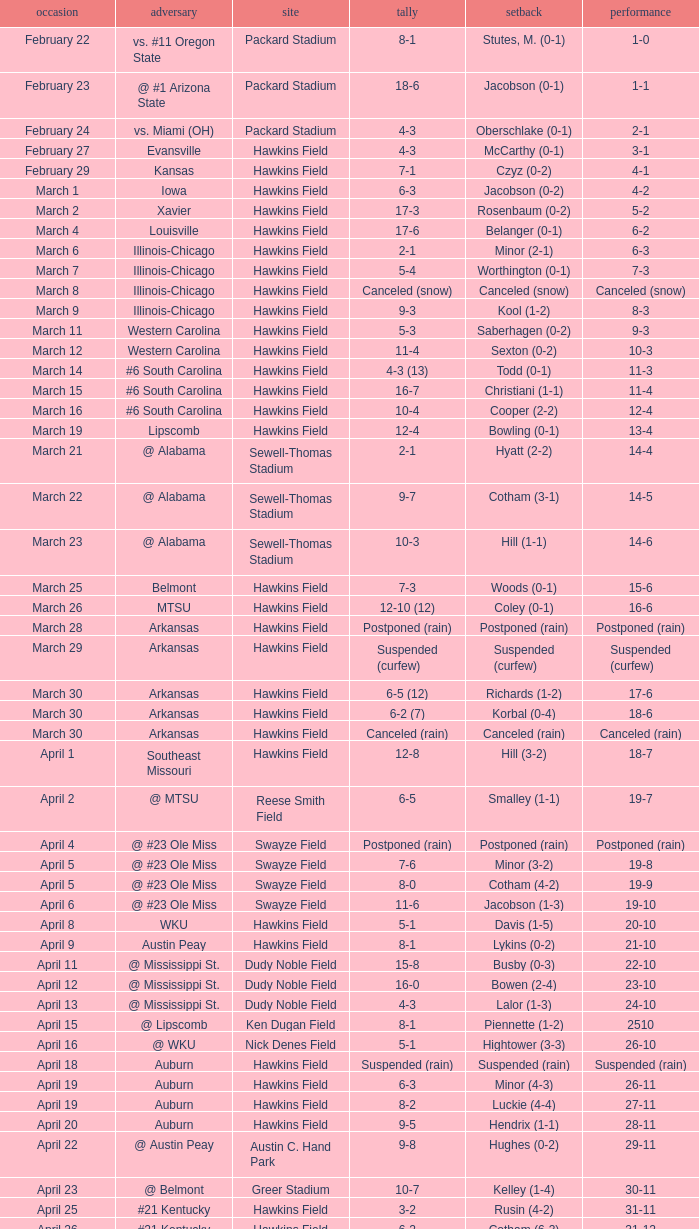Could you parse the entire table as a dict? {'header': ['occasion', 'adversary', 'site', 'tally', 'setback', 'performance'], 'rows': [['February 22', 'vs. #11 Oregon State', 'Packard Stadium', '8-1', 'Stutes, M. (0-1)', '1-0'], ['February 23', '@ #1 Arizona State', 'Packard Stadium', '18-6', 'Jacobson (0-1)', '1-1'], ['February 24', 'vs. Miami (OH)', 'Packard Stadium', '4-3', 'Oberschlake (0-1)', '2-1'], ['February 27', 'Evansville', 'Hawkins Field', '4-3', 'McCarthy (0-1)', '3-1'], ['February 29', 'Kansas', 'Hawkins Field', '7-1', 'Czyz (0-2)', '4-1'], ['March 1', 'Iowa', 'Hawkins Field', '6-3', 'Jacobson (0-2)', '4-2'], ['March 2', 'Xavier', 'Hawkins Field', '17-3', 'Rosenbaum (0-2)', '5-2'], ['March 4', 'Louisville', 'Hawkins Field', '17-6', 'Belanger (0-1)', '6-2'], ['March 6', 'Illinois-Chicago', 'Hawkins Field', '2-1', 'Minor (2-1)', '6-3'], ['March 7', 'Illinois-Chicago', 'Hawkins Field', '5-4', 'Worthington (0-1)', '7-3'], ['March 8', 'Illinois-Chicago', 'Hawkins Field', 'Canceled (snow)', 'Canceled (snow)', 'Canceled (snow)'], ['March 9', 'Illinois-Chicago', 'Hawkins Field', '9-3', 'Kool (1-2)', '8-3'], ['March 11', 'Western Carolina', 'Hawkins Field', '5-3', 'Saberhagen (0-2)', '9-3'], ['March 12', 'Western Carolina', 'Hawkins Field', '11-4', 'Sexton (0-2)', '10-3'], ['March 14', '#6 South Carolina', 'Hawkins Field', '4-3 (13)', 'Todd (0-1)', '11-3'], ['March 15', '#6 South Carolina', 'Hawkins Field', '16-7', 'Christiani (1-1)', '11-4'], ['March 16', '#6 South Carolina', 'Hawkins Field', '10-4', 'Cooper (2-2)', '12-4'], ['March 19', 'Lipscomb', 'Hawkins Field', '12-4', 'Bowling (0-1)', '13-4'], ['March 21', '@ Alabama', 'Sewell-Thomas Stadium', '2-1', 'Hyatt (2-2)', '14-4'], ['March 22', '@ Alabama', 'Sewell-Thomas Stadium', '9-7', 'Cotham (3-1)', '14-5'], ['March 23', '@ Alabama', 'Sewell-Thomas Stadium', '10-3', 'Hill (1-1)', '14-6'], ['March 25', 'Belmont', 'Hawkins Field', '7-3', 'Woods (0-1)', '15-6'], ['March 26', 'MTSU', 'Hawkins Field', '12-10 (12)', 'Coley (0-1)', '16-6'], ['March 28', 'Arkansas', 'Hawkins Field', 'Postponed (rain)', 'Postponed (rain)', 'Postponed (rain)'], ['March 29', 'Arkansas', 'Hawkins Field', 'Suspended (curfew)', 'Suspended (curfew)', 'Suspended (curfew)'], ['March 30', 'Arkansas', 'Hawkins Field', '6-5 (12)', 'Richards (1-2)', '17-6'], ['March 30', 'Arkansas', 'Hawkins Field', '6-2 (7)', 'Korbal (0-4)', '18-6'], ['March 30', 'Arkansas', 'Hawkins Field', 'Canceled (rain)', 'Canceled (rain)', 'Canceled (rain)'], ['April 1', 'Southeast Missouri', 'Hawkins Field', '12-8', 'Hill (3-2)', '18-7'], ['April 2', '@ MTSU', 'Reese Smith Field', '6-5', 'Smalley (1-1)', '19-7'], ['April 4', '@ #23 Ole Miss', 'Swayze Field', 'Postponed (rain)', 'Postponed (rain)', 'Postponed (rain)'], ['April 5', '@ #23 Ole Miss', 'Swayze Field', '7-6', 'Minor (3-2)', '19-8'], ['April 5', '@ #23 Ole Miss', 'Swayze Field', '8-0', 'Cotham (4-2)', '19-9'], ['April 6', '@ #23 Ole Miss', 'Swayze Field', '11-6', 'Jacobson (1-3)', '19-10'], ['April 8', 'WKU', 'Hawkins Field', '5-1', 'Davis (1-5)', '20-10'], ['April 9', 'Austin Peay', 'Hawkins Field', '8-1', 'Lykins (0-2)', '21-10'], ['April 11', '@ Mississippi St.', 'Dudy Noble Field', '15-8', 'Busby (0-3)', '22-10'], ['April 12', '@ Mississippi St.', 'Dudy Noble Field', '16-0', 'Bowen (2-4)', '23-10'], ['April 13', '@ Mississippi St.', 'Dudy Noble Field', '4-3', 'Lalor (1-3)', '24-10'], ['April 15', '@ Lipscomb', 'Ken Dugan Field', '8-1', 'Piennette (1-2)', '2510'], ['April 16', '@ WKU', 'Nick Denes Field', '5-1', 'Hightower (3-3)', '26-10'], ['April 18', 'Auburn', 'Hawkins Field', 'Suspended (rain)', 'Suspended (rain)', 'Suspended (rain)'], ['April 19', 'Auburn', 'Hawkins Field', '6-3', 'Minor (4-3)', '26-11'], ['April 19', 'Auburn', 'Hawkins Field', '8-2', 'Luckie (4-4)', '27-11'], ['April 20', 'Auburn', 'Hawkins Field', '9-5', 'Hendrix (1-1)', '28-11'], ['April 22', '@ Austin Peay', 'Austin C. Hand Park', '9-8', 'Hughes (0-2)', '29-11'], ['April 23', '@ Belmont', 'Greer Stadium', '10-7', 'Kelley (1-4)', '30-11'], ['April 25', '#21 Kentucky', 'Hawkins Field', '3-2', 'Rusin (4-2)', '31-11'], ['April 26', '#21 Kentucky', 'Hawkins Field', '6-2', 'Cotham (6-3)', '31-12'], ['April 27', '#21 Kentucky', 'Hawkins Field', '3-1', 'Christiani (5-2)', '31-13'], ['May 2', '@ Tennessee', 'Lindsey Nelson Stadium', '8-5', 'Hernandez (1-4)', '32-13'], ['May 3', '@ Tennessee', 'Lindsey Nelson Stadium', '9-2', 'Morgado (5-3)', '33-13'], ['May 4', '@ Tennessee', 'Lindsey Nelson Stadium', '10-8', 'Wiltz (3-2)', '34-13'], ['May 6', 'vs. Memphis', 'Pringles Park', '8-0', 'Martin (4-3)', '35-13'], ['May 7', 'Tennessee Tech', 'Hawkins Field', '7-2', 'Liberatore (1-1)', '36-13'], ['May 9', '#9 Georgia', 'Hawkins Field', '13-7', 'Holder (7-3)', '37-13'], ['May 10', '#9 Georgia', 'Hawkins Field', '4-2 (10)', 'Brewer (4-1)', '37-14'], ['May 11', '#9 Georgia', 'Hawkins Field', '12-10', 'Christiani (5-3)', '37-15'], ['May 15', '@ Florida', 'McKethan Stadium', '8-6', 'Brewer (4-2)', '37-16'], ['May 16', '@ Florida', 'McKethan Stadium', '5-4', 'Cotham (7-4)', '37-17'], ['May 17', '@ Florida', 'McKethan Stadium', '13-12 (11)', 'Jacobson (1-4)', '37-18']]} What was the location of the game when the record was 2-1? Packard Stadium. 